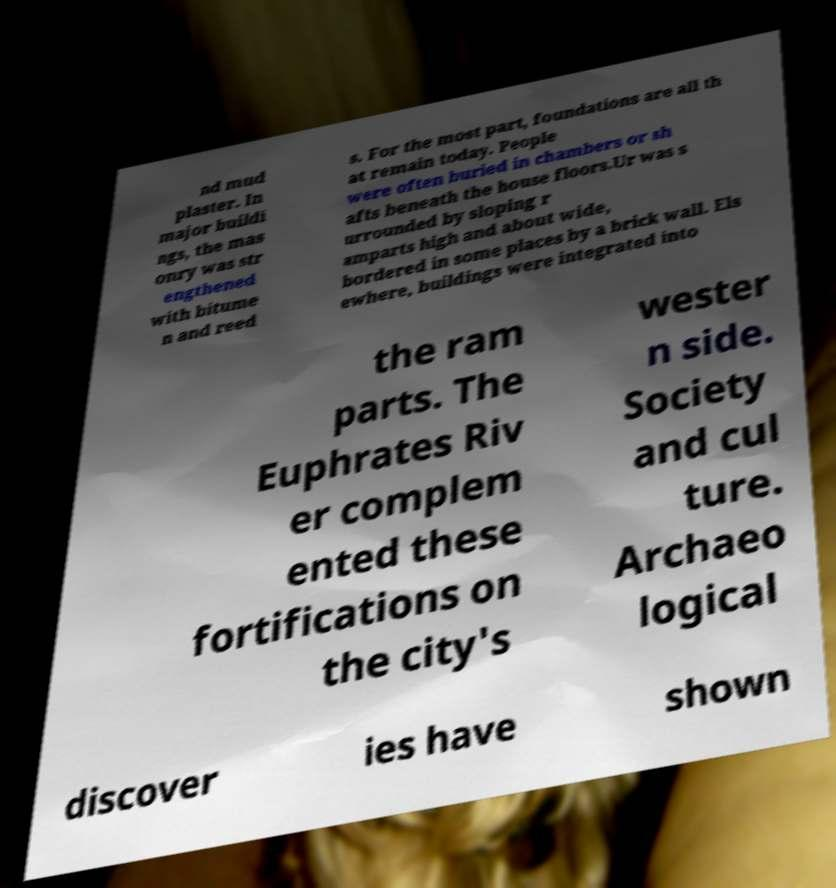I need the written content from this picture converted into text. Can you do that? nd mud plaster. In major buildi ngs, the mas onry was str engthened with bitume n and reed s. For the most part, foundations are all th at remain today. People were often buried in chambers or sh afts beneath the house floors.Ur was s urrounded by sloping r amparts high and about wide, bordered in some places by a brick wall. Els ewhere, buildings were integrated into the ram parts. The Euphrates Riv er complem ented these fortifications on the city's wester n side. Society and cul ture. Archaeo logical discover ies have shown 